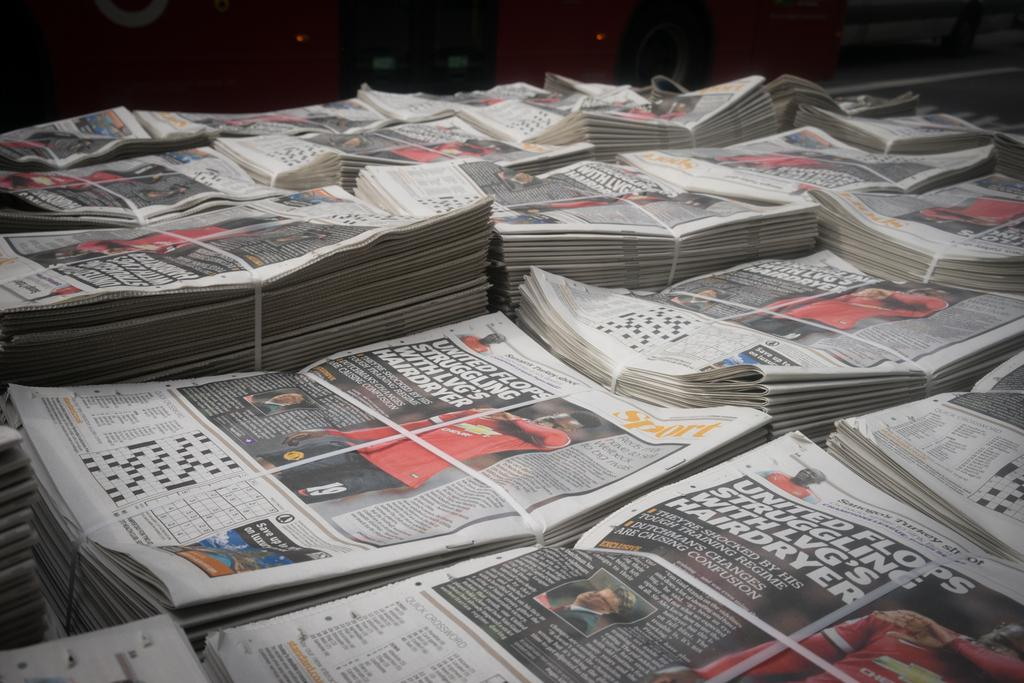What is the main subject of the image? The main subject of the image is newspaper bundles. Can you describe the objects in the background of the image? Unfortunately, the provided facts do not give any information about the objects in the background of the image. How does the earthquake affect the newspaper bundles in the image? There is no earthquake present in the image, so its effects cannot be observed. 